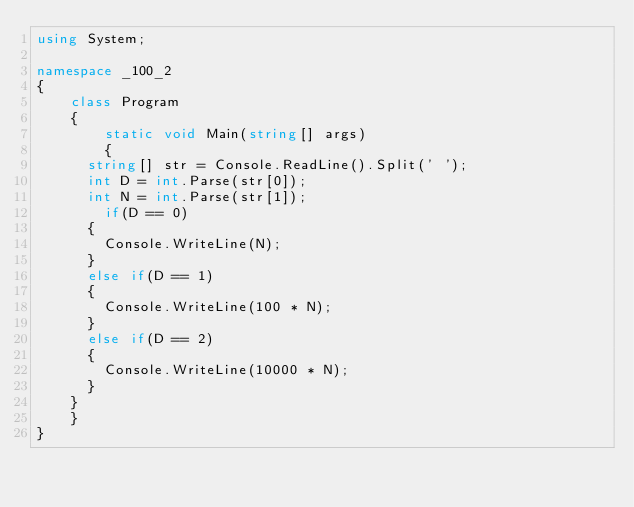<code> <loc_0><loc_0><loc_500><loc_500><_C#_>using System;

namespace _100_2
{
    class Program
    {
        static void Main(string[] args)
        {
			string[] str = Console.ReadLine().Split(' ');
			int D = int.Parse(str[0]);
			int N = int.Parse(str[1]);
		    if(D == 0)
			{
				Console.WriteLine(N);
			}
			else if(D == 1)
			{
				Console.WriteLine(100 * N);
			}
			else if(D == 2)
			{
				Console.WriteLine(10000 * N);
			}
		}
    }
}
</code> 